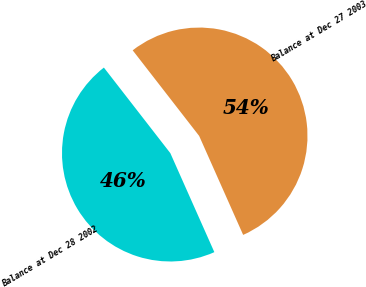<chart> <loc_0><loc_0><loc_500><loc_500><pie_chart><fcel>Balance at Dec 28 2002<fcel>Balance at Dec 27 2003<nl><fcel>46.15%<fcel>53.85%<nl></chart> 